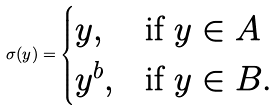Convert formula to latex. <formula><loc_0><loc_0><loc_500><loc_500>\sigma ( y ) = \begin{cases} y , & \text {if } y \in A \\ y ^ { b } , & \text {if } y \in B . \end{cases}</formula> 